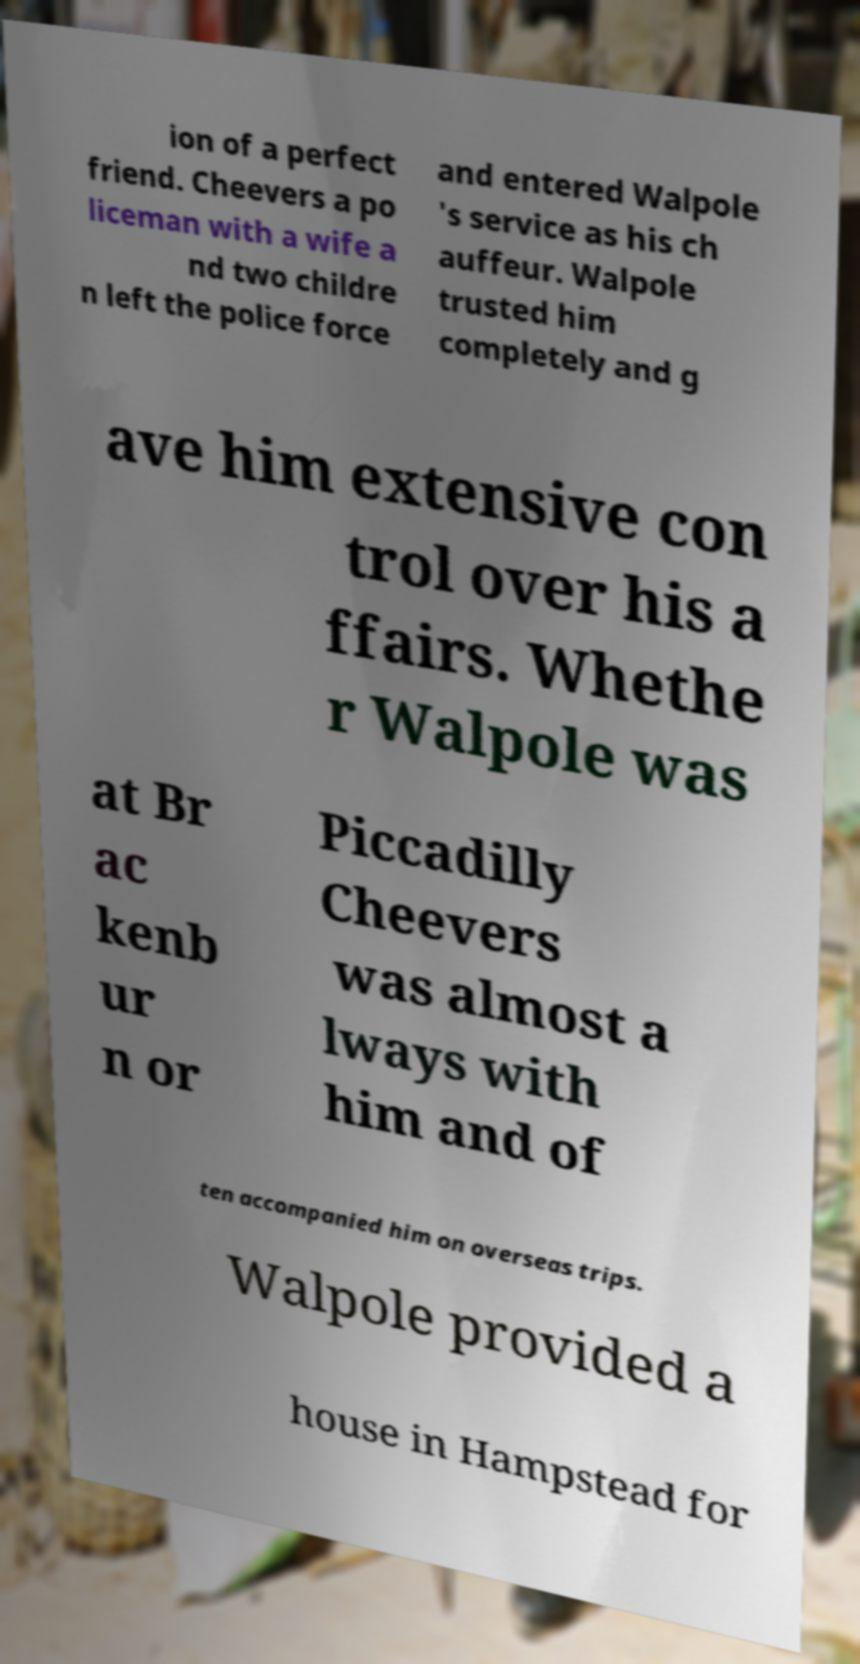Can you read and provide the text displayed in the image?This photo seems to have some interesting text. Can you extract and type it out for me? ion of a perfect friend. Cheevers a po liceman with a wife a nd two childre n left the police force and entered Walpole 's service as his ch auffeur. Walpole trusted him completely and g ave him extensive con trol over his a ffairs. Whethe r Walpole was at Br ac kenb ur n or Piccadilly Cheevers was almost a lways with him and of ten accompanied him on overseas trips. Walpole provided a house in Hampstead for 